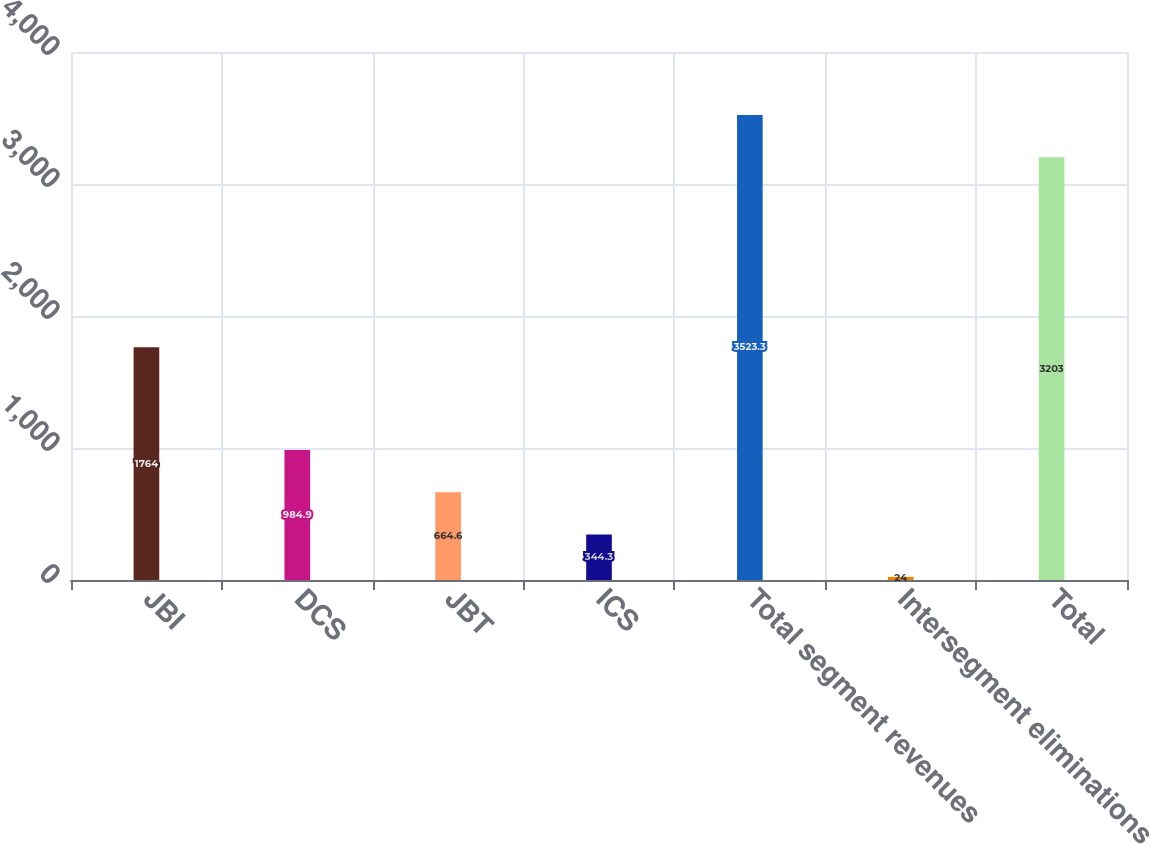Convert chart. <chart><loc_0><loc_0><loc_500><loc_500><bar_chart><fcel>JBI<fcel>DCS<fcel>JBT<fcel>ICS<fcel>Total segment revenues<fcel>Intersegment eliminations<fcel>Total<nl><fcel>1764<fcel>984.9<fcel>664.6<fcel>344.3<fcel>3523.3<fcel>24<fcel>3203<nl></chart> 